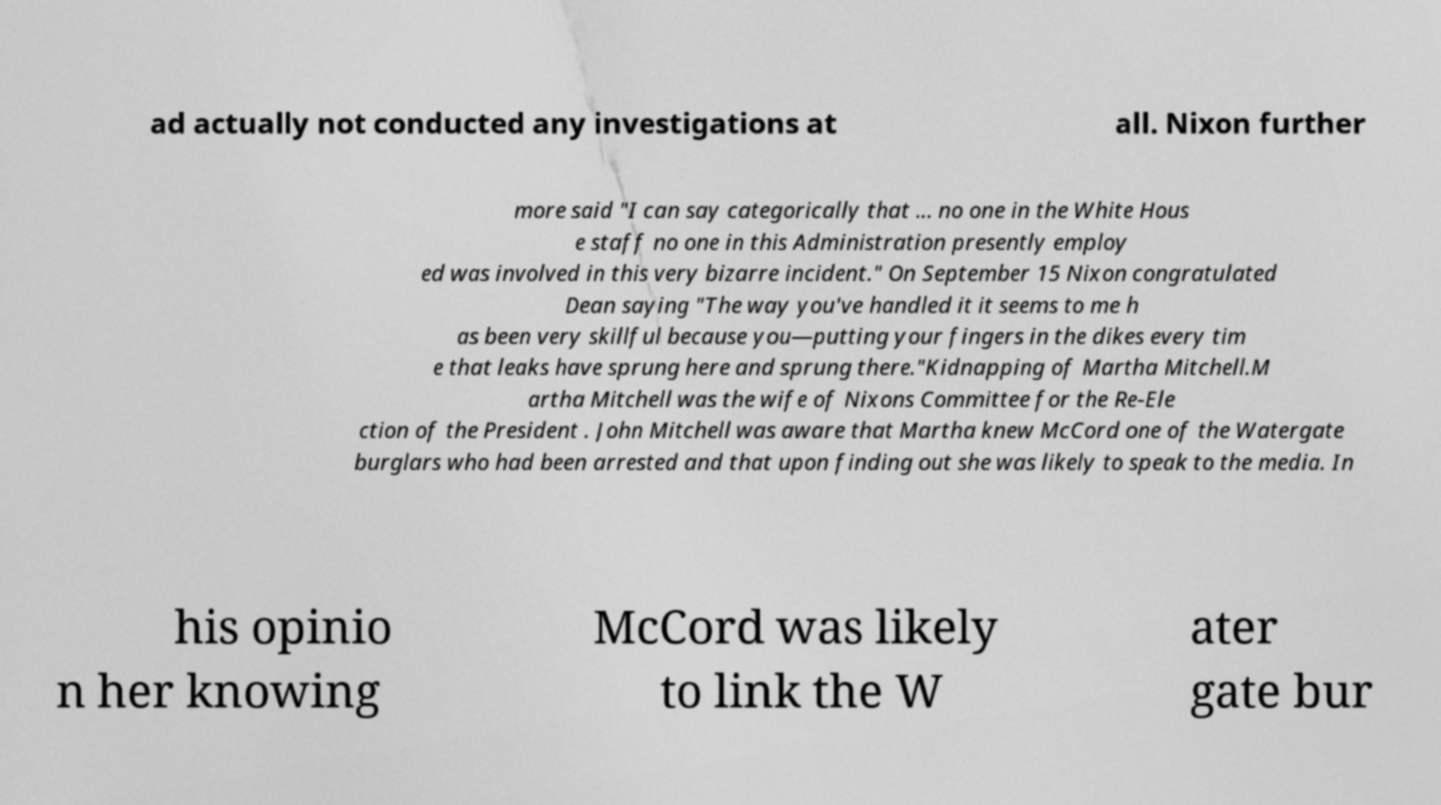Please read and relay the text visible in this image. What does it say? ad actually not conducted any investigations at all. Nixon further more said "I can say categorically that ... no one in the White Hous e staff no one in this Administration presently employ ed was involved in this very bizarre incident." On September 15 Nixon congratulated Dean saying "The way you've handled it it seems to me h as been very skillful because you—putting your fingers in the dikes every tim e that leaks have sprung here and sprung there."Kidnapping of Martha Mitchell.M artha Mitchell was the wife of Nixons Committee for the Re-Ele ction of the President . John Mitchell was aware that Martha knew McCord one of the Watergate burglars who had been arrested and that upon finding out she was likely to speak to the media. In his opinio n her knowing McCord was likely to link the W ater gate bur 